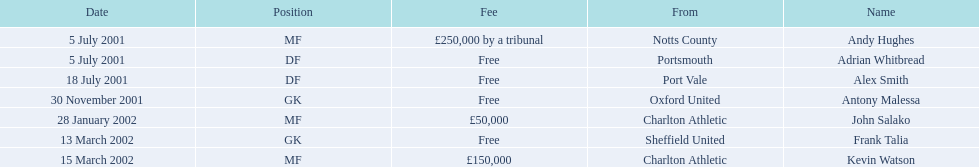Are there at least 2 nationalities on the chart? Yes. 